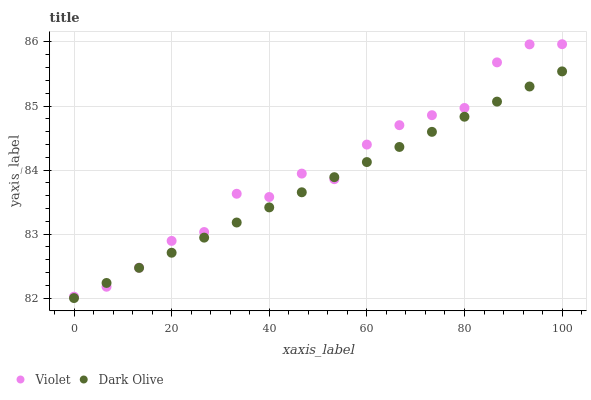Does Dark Olive have the minimum area under the curve?
Answer yes or no. Yes. Does Violet have the maximum area under the curve?
Answer yes or no. Yes. Does Violet have the minimum area under the curve?
Answer yes or no. No. Is Dark Olive the smoothest?
Answer yes or no. Yes. Is Violet the roughest?
Answer yes or no. Yes. Is Violet the smoothest?
Answer yes or no. No. Does Dark Olive have the lowest value?
Answer yes or no. Yes. Does Violet have the lowest value?
Answer yes or no. No. Does Violet have the highest value?
Answer yes or no. Yes. Does Dark Olive intersect Violet?
Answer yes or no. Yes. Is Dark Olive less than Violet?
Answer yes or no. No. Is Dark Olive greater than Violet?
Answer yes or no. No. 